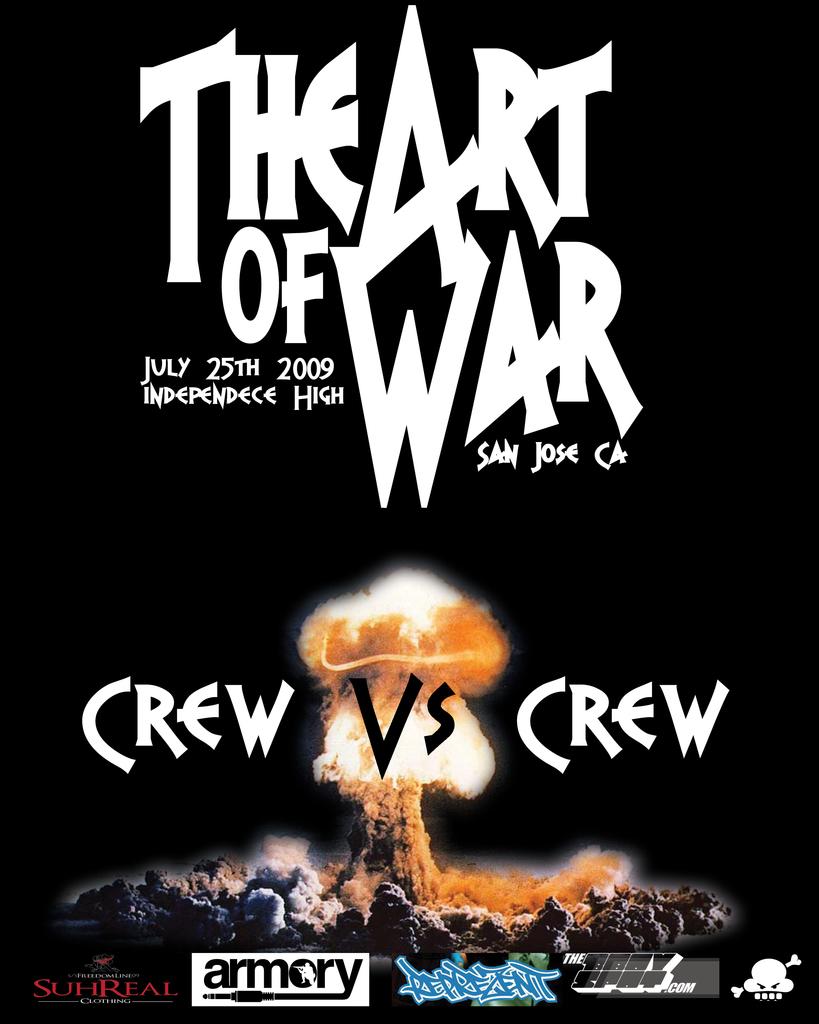What date will this event be held?
Give a very brief answer. July 25th 2009. 